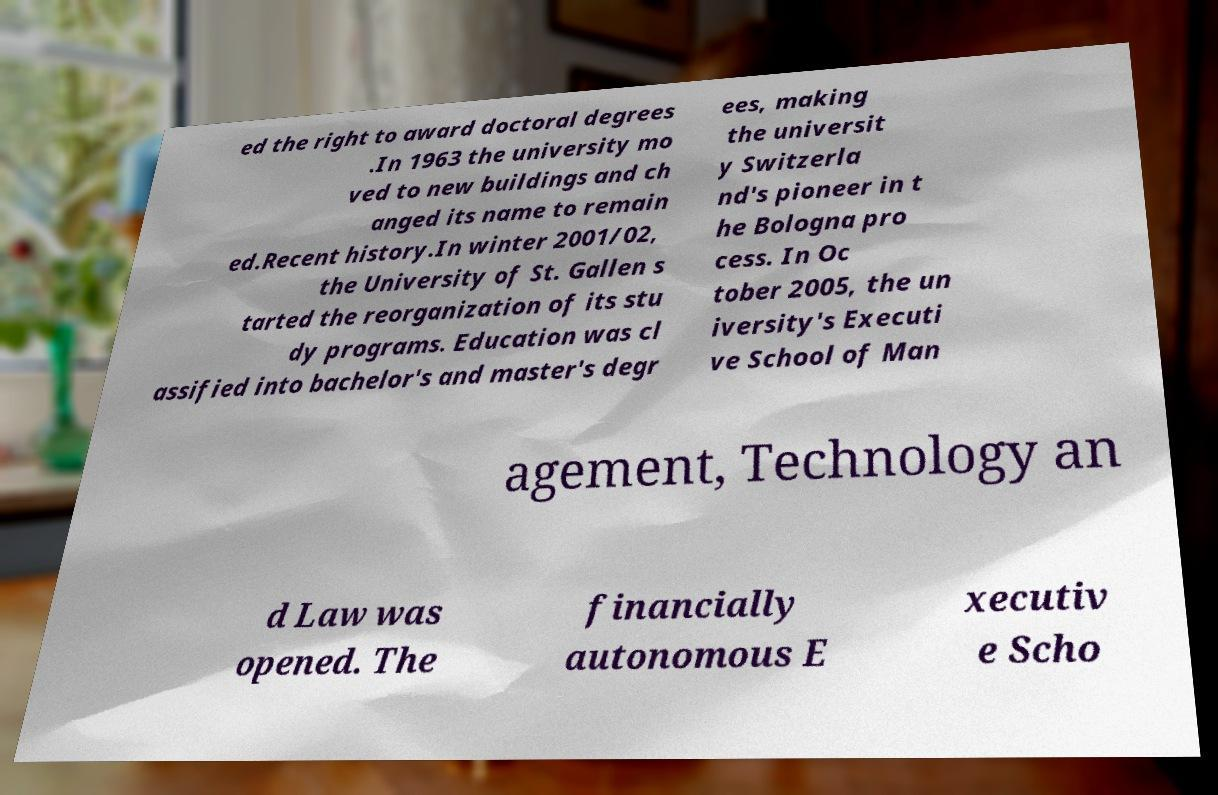For documentation purposes, I need the text within this image transcribed. Could you provide that? ed the right to award doctoral degrees .In 1963 the university mo ved to new buildings and ch anged its name to remain ed.Recent history.In winter 2001/02, the University of St. Gallen s tarted the reorganization of its stu dy programs. Education was cl assified into bachelor's and master's degr ees, making the universit y Switzerla nd's pioneer in t he Bologna pro cess. In Oc tober 2005, the un iversity's Executi ve School of Man agement, Technology an d Law was opened. The financially autonomous E xecutiv e Scho 